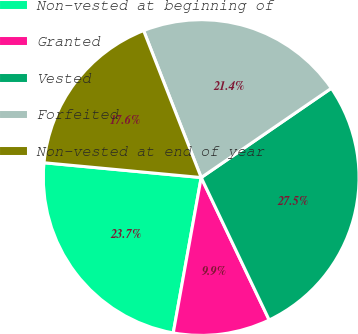Convert chart. <chart><loc_0><loc_0><loc_500><loc_500><pie_chart><fcel>Non-vested at beginning of<fcel>Granted<fcel>Vested<fcel>Forfeited<fcel>Non-vested at end of year<nl><fcel>23.66%<fcel>9.92%<fcel>27.48%<fcel>21.37%<fcel>17.56%<nl></chart> 